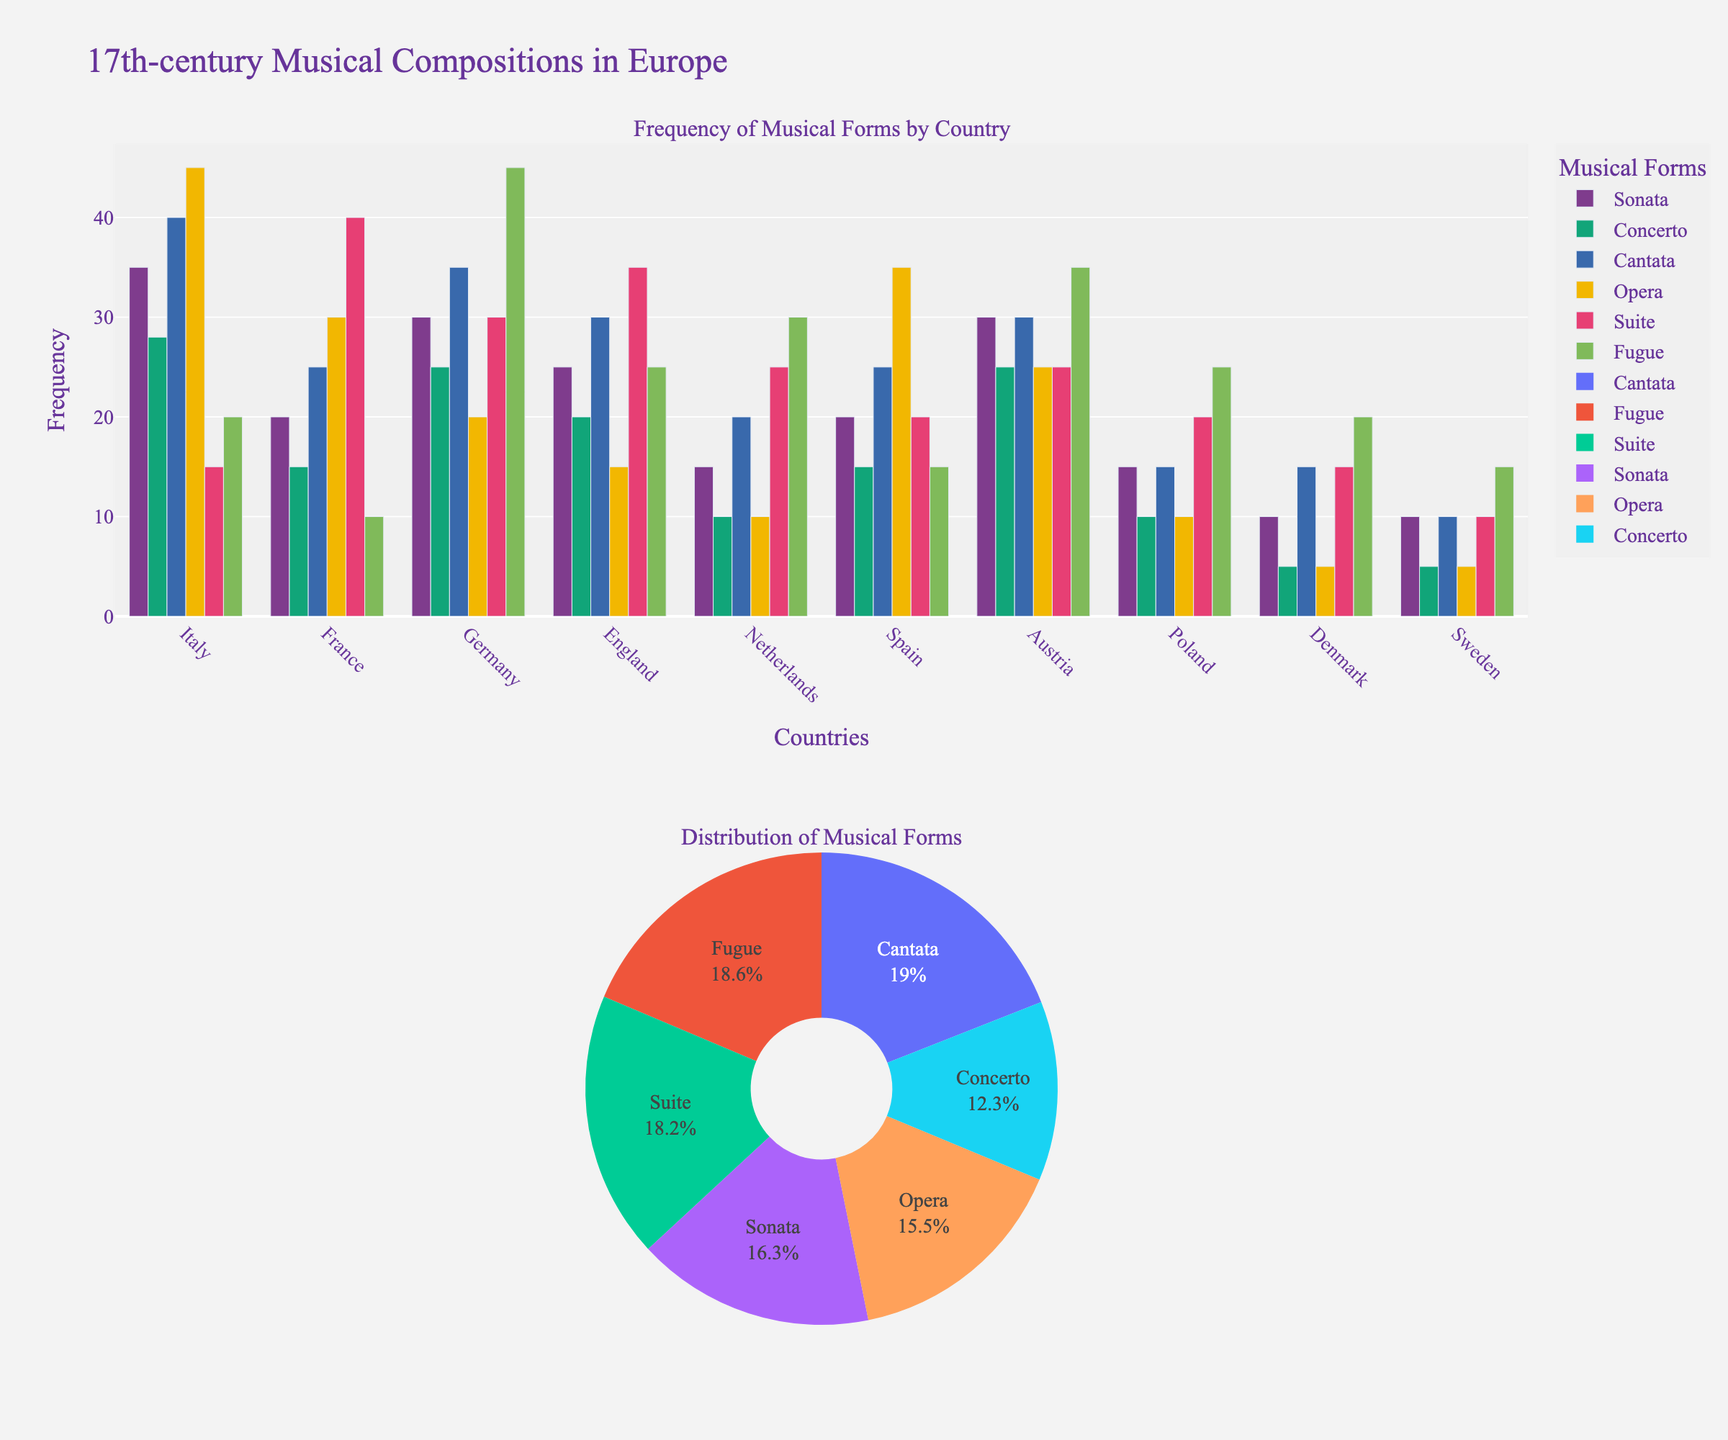Which country has the highest frequency of Operas? From the bar chart in the first subplot, the height of the bar representing Operas for Italy is the highest among all countries.
Answer: Italy What is the total frequency of Suits across all countries? Sum the heights or values of the bars corresponding to Suits in all countries: 15 + 40 + 30 + 35 + 25 + 20 + 25 + 20 + 15 + 10 = 235
Answer: 235 Which three countries have the lowest frequency of Concertos, and what is the sum of their frequencies? From the bar chart, the three lowest frequencies for Concertos are Sweden (5), Denmark (5), and Netherlands (10). Summing them: 5 + 5 + 10 = 20
Answer: Sweden, Denmark, Netherlands; 20 In which country is the frequency of Fugues exactly equal to twice the frequency of Sonatas? Comparing the heights of the Fugues and Sonatas bars, Germany has a frequency of Fugues (45), which is twice that of Sonatas (30).
Answer: Germany Compare the frequency of Cantatas in France and England and determine the higher value. By inspecting the bar heights, France has 25 Cantatas, while England has 30 Cantatas. England’s value is higher.
Answer: England Which musical form has the largest proportion in the pie chart? From the pie chart in the second subplot, each segment's size reveals that Cantatas have the largest proportion.
Answer: Cantatas Find the average frequency of Operas in the listed countries. Retrieve the frequency values for Operas: 45, 30, 20, 15, 10, 35, 25, 10, 5, 5. Sum these and divide by the number of countries: (45 + 30 + 20 + 15 + 10 + 35 + 25 + 10 + 5+ 5) / 10 = 20
Answer: 20 What is the difference in the frequency of Suites between France and Italy? The frequency of Suites in France is 40, and in Italy, it is 15. The difference is 40 - 15 = 25.
Answer: 25 Determine the sum of the frequencies of musical forms in Spain. Add the frequencies for all musical forms in Spain: 20 + 15 + 25 + 35 + 20 + 15 = 130.
Answer: 130 Which country has exactly the same frequency for Fugues and Suites? From the bar chart, Austria has the same frequency for Fugues and Suites, both being 25.
Answer: Austria 